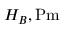<formula> <loc_0><loc_0><loc_500><loc_500>H _ { B } , { P m }</formula> 